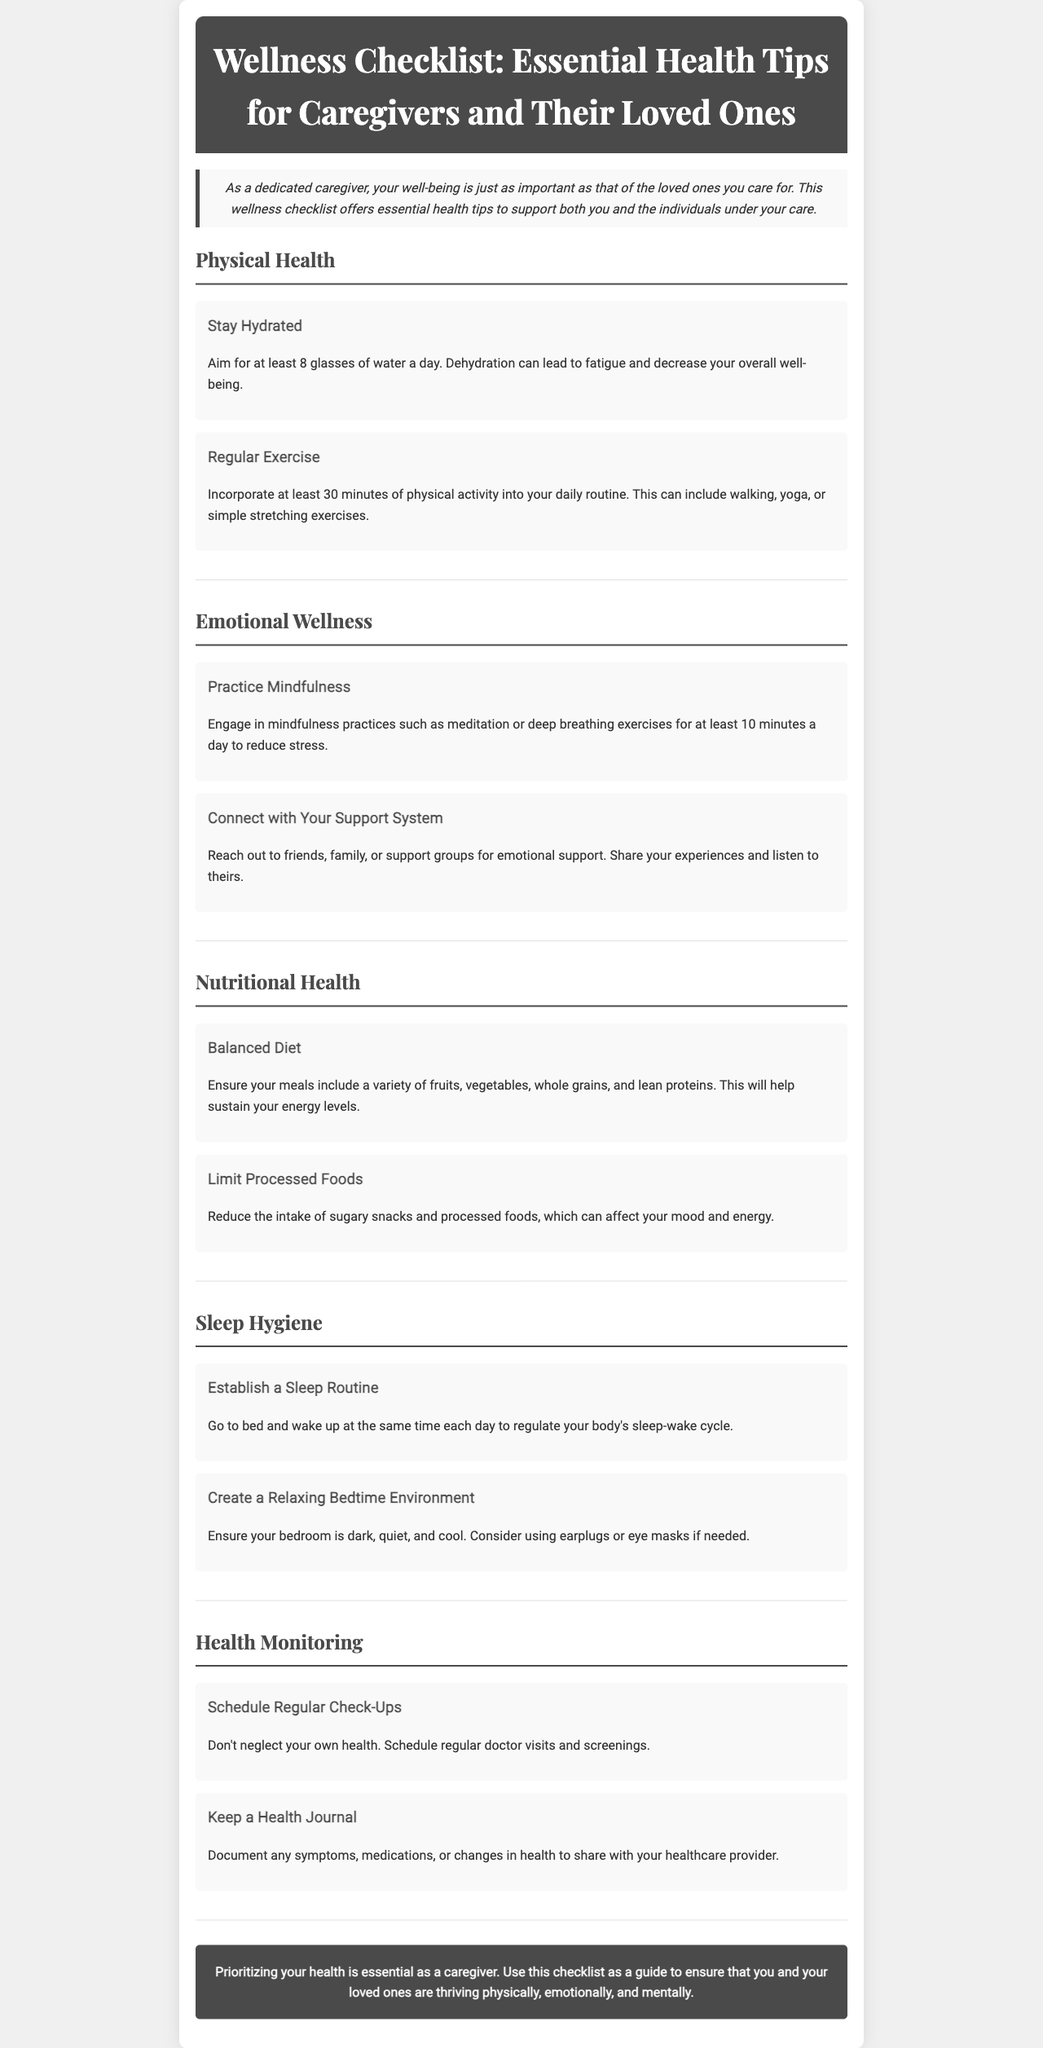What is the title of the newsletter? The title is stated at the top of the document in a prominent header section.
Answer: Wellness Checklist: Essential Health Tips for Caregivers and Their Loved Ones How many glasses of water should you aim for daily? The document provides specific recommendations for hydration in the physical health section.
Answer: 8 glasses What type of exercise is suggested in the wellness checklist? The checklist gives examples of physical activities that can be included in a daily routine.
Answer: Walking What practice is recommended to reduce stress? The document lists specific emotional wellness practices that can help caregivers manage stress.
Answer: Mindfulness What component of health does the tip about “Create a Relaxing Bedtime Environment” address? The tip is categorized under sleep hygiene in the document, which focuses on sleeping well.
Answer: Sleep Hygiene How should you approach your health monitoring according to the checklist? The checklist specifies the importance of keeping track of one's health with regular check-ups and a health journal.
Answer: Schedule Regular Check-Ups What type of diet is encouraged in the nutritional health section? The checklist emphasizes the types of food that should be included in one’s diet for better energy levels.
Answer: Balanced Diet What is a key emotional wellness tip provided in the document? The checklist offers guidance on connecting with others for support, which is part of emotional wellness.
Answer: Connect with Your Support System What is the tone of the introduction? The introduction section sets the context and importance of the checklist for caregivers, indicating a supportive and informative tone.
Answer: Supportive 